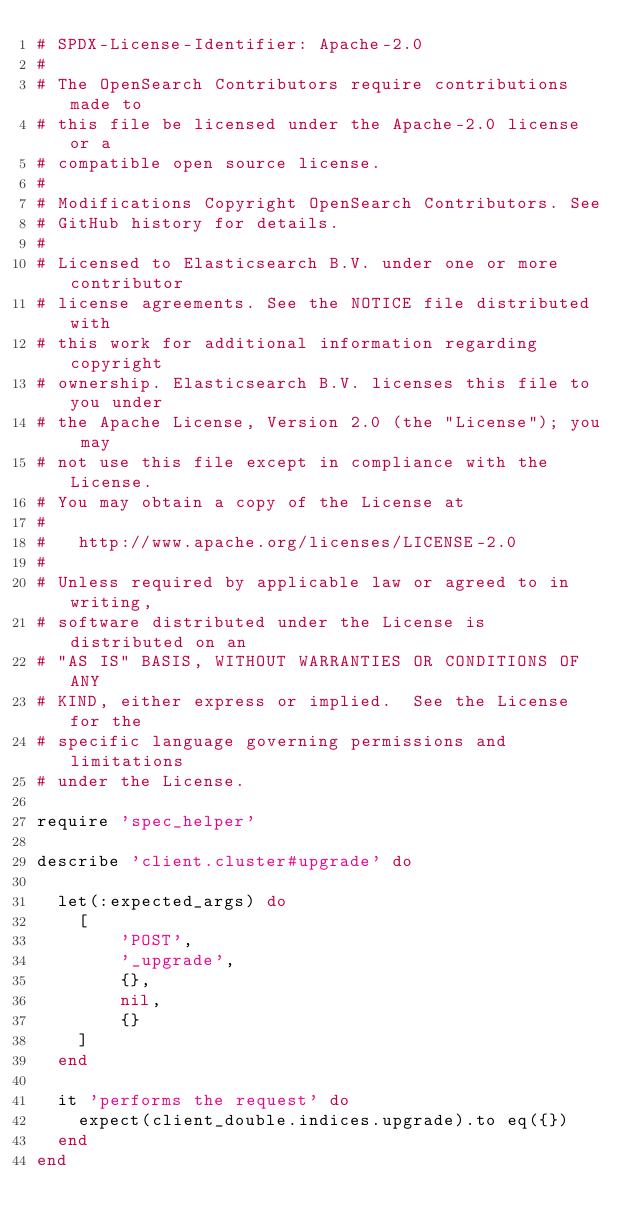<code> <loc_0><loc_0><loc_500><loc_500><_Ruby_># SPDX-License-Identifier: Apache-2.0
#
# The OpenSearch Contributors require contributions made to
# this file be licensed under the Apache-2.0 license or a
# compatible open source license.
#
# Modifications Copyright OpenSearch Contributors. See
# GitHub history for details.
#
# Licensed to Elasticsearch B.V. under one or more contributor
# license agreements. See the NOTICE file distributed with
# this work for additional information regarding copyright
# ownership. Elasticsearch B.V. licenses this file to you under
# the Apache License, Version 2.0 (the "License"); you may
# not use this file except in compliance with the License.
# You may obtain a copy of the License at
#
#   http://www.apache.org/licenses/LICENSE-2.0
#
# Unless required by applicable law or agreed to in writing,
# software distributed under the License is distributed on an
# "AS IS" BASIS, WITHOUT WARRANTIES OR CONDITIONS OF ANY
# KIND, either express or implied.  See the License for the
# specific language governing permissions and limitations
# under the License.

require 'spec_helper'

describe 'client.cluster#upgrade' do

  let(:expected_args) do
    [
        'POST',
        '_upgrade',
        {},
        nil,
        {}
    ]
  end

  it 'performs the request' do
    expect(client_double.indices.upgrade).to eq({})
  end
end
</code> 